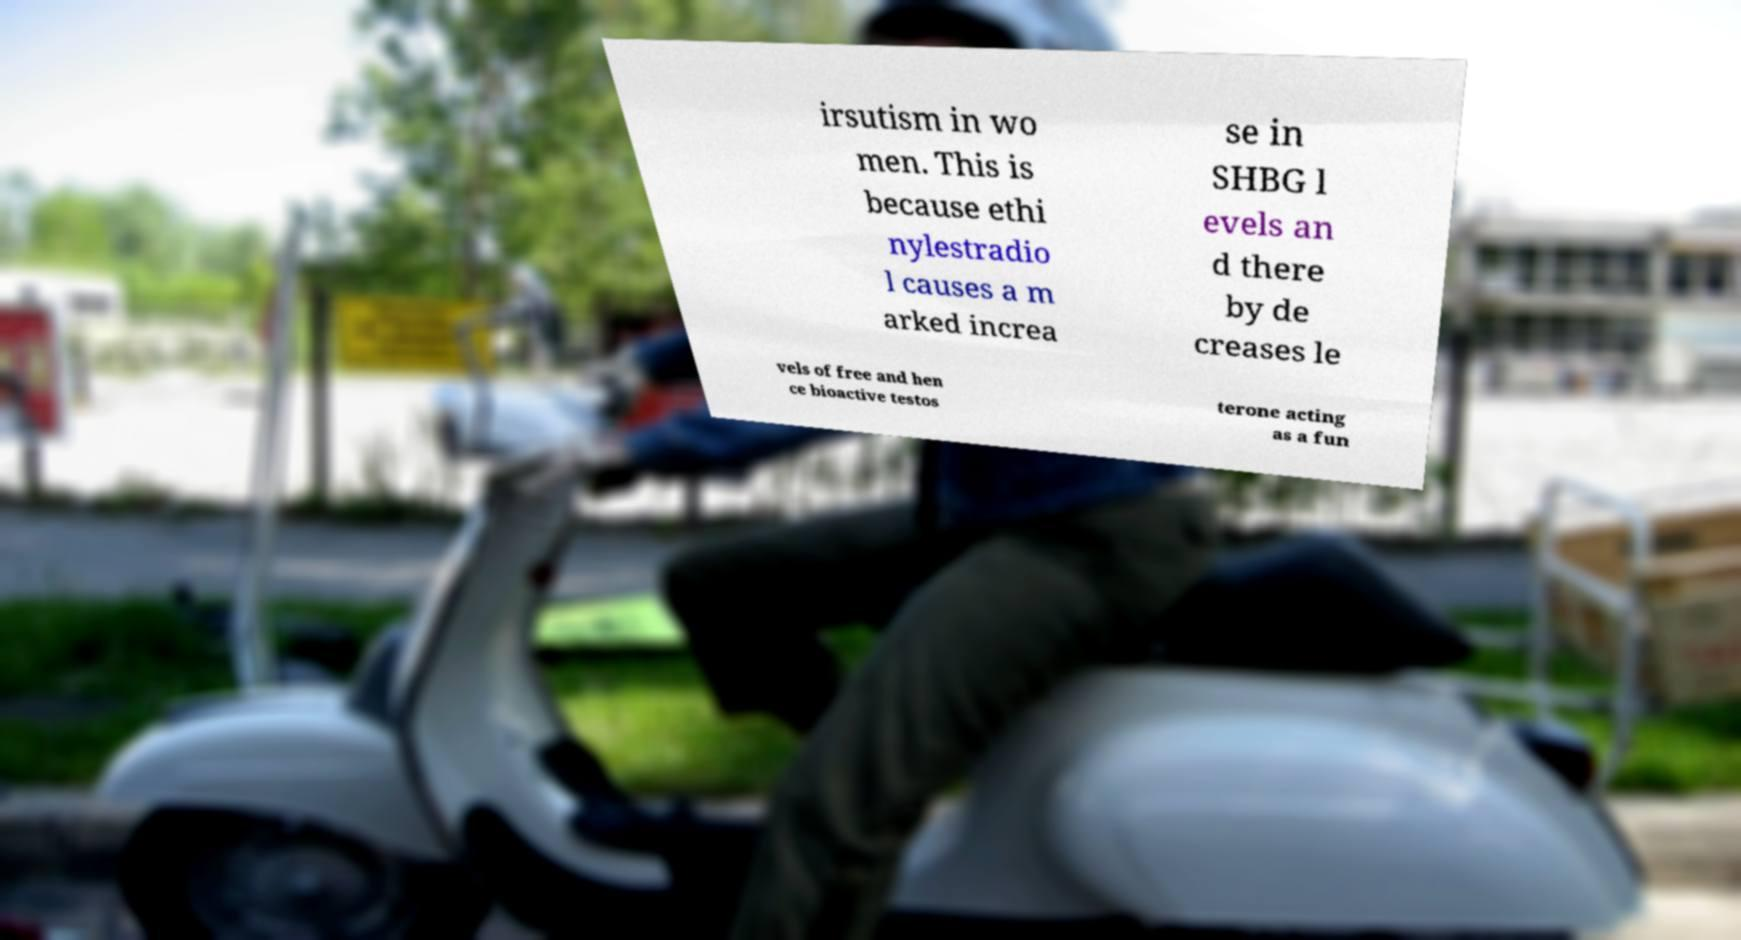Could you assist in decoding the text presented in this image and type it out clearly? irsutism in wo men. This is because ethi nylestradio l causes a m arked increa se in SHBG l evels an d there by de creases le vels of free and hen ce bioactive testos terone acting as a fun 